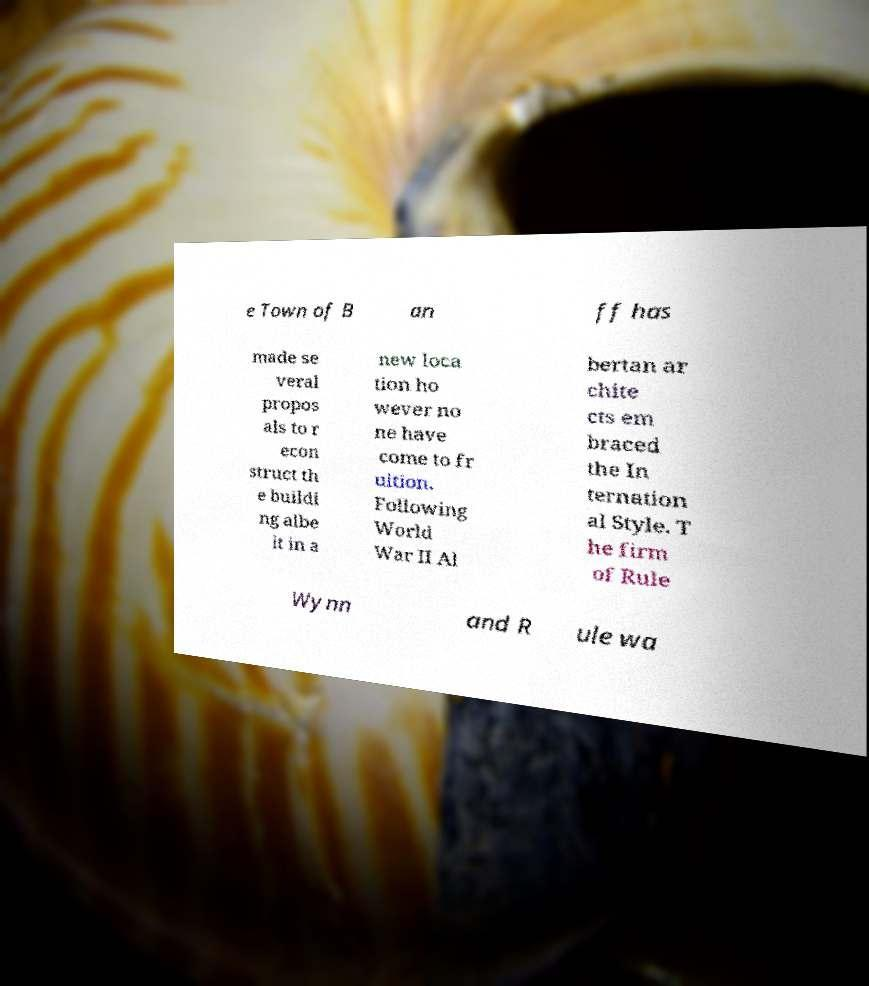Could you assist in decoding the text presented in this image and type it out clearly? e Town of B an ff has made se veral propos als to r econ struct th e buildi ng albe it in a new loca tion ho wever no ne have come to fr uition. Following World War II Al bertan ar chite cts em braced the In ternation al Style. T he firm of Rule Wynn and R ule wa 